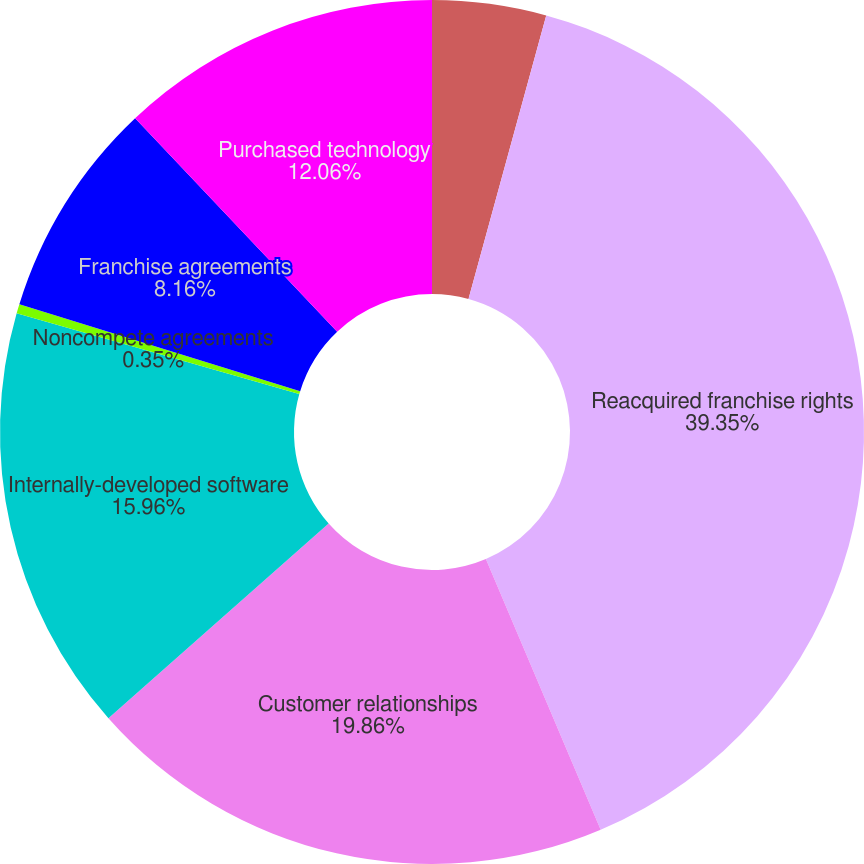Convert chart to OTSL. <chart><loc_0><loc_0><loc_500><loc_500><pie_chart><fcel>As of April 30<fcel>Reacquired franchise rights<fcel>Customer relationships<fcel>Internally-developed software<fcel>Noncompete agreements<fcel>Franchise agreements<fcel>Purchased technology<nl><fcel>4.26%<fcel>39.36%<fcel>19.86%<fcel>15.96%<fcel>0.35%<fcel>8.16%<fcel>12.06%<nl></chart> 